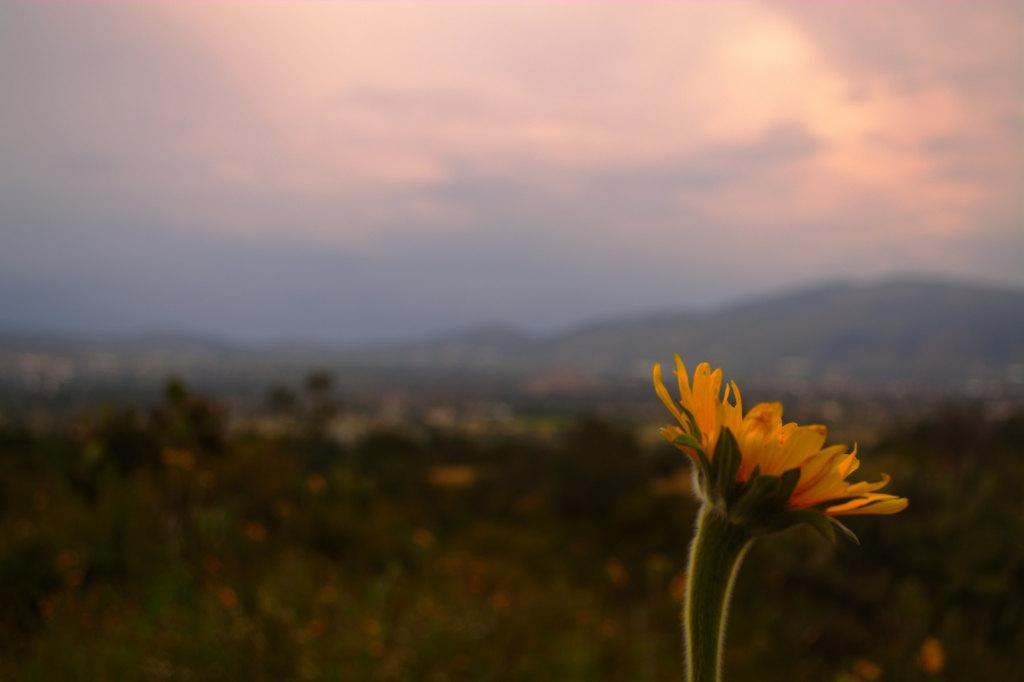How many yellow flowers can be seen in the image? There are two yellow flowers in the image. What is the quality of the background in the image? The background of the image is slightly blurred. What type of natural features can be seen in the background of the image? Trees, hills, and a cloudy sky are visible in the background of the image. Where is the snail hiding in the image? There is no snail present in the image. Is the image a print or a digital photograph? The information provided does not specify whether the image is a print or a digital photograph. 